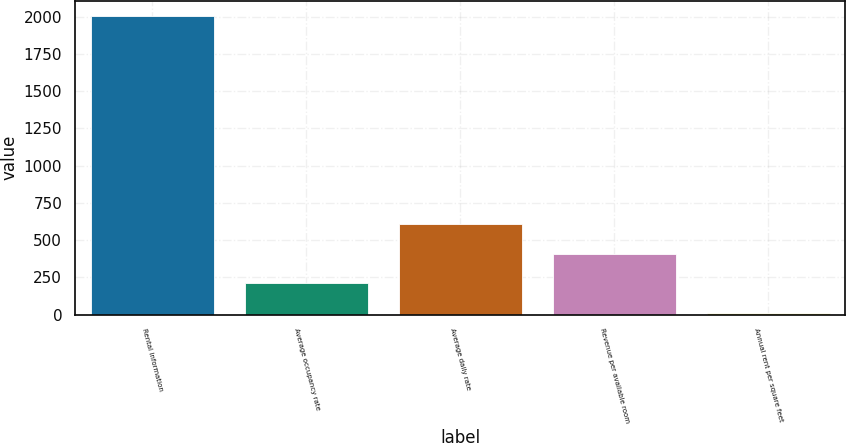<chart> <loc_0><loc_0><loc_500><loc_500><bar_chart><fcel>Rental information<fcel>Average occupancy rate<fcel>Average daily rate<fcel>Revenue per available room<fcel>Annual rent per square feet<nl><fcel>2005<fcel>210.13<fcel>608.99<fcel>409.56<fcel>10.7<nl></chart> 